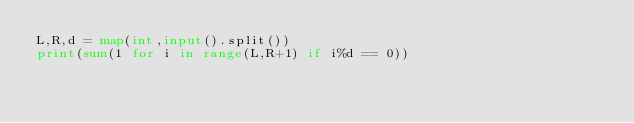<code> <loc_0><loc_0><loc_500><loc_500><_Python_>L,R,d = map(int,input().split())
print(sum(1 for i in range(L,R+1) if i%d == 0))</code> 